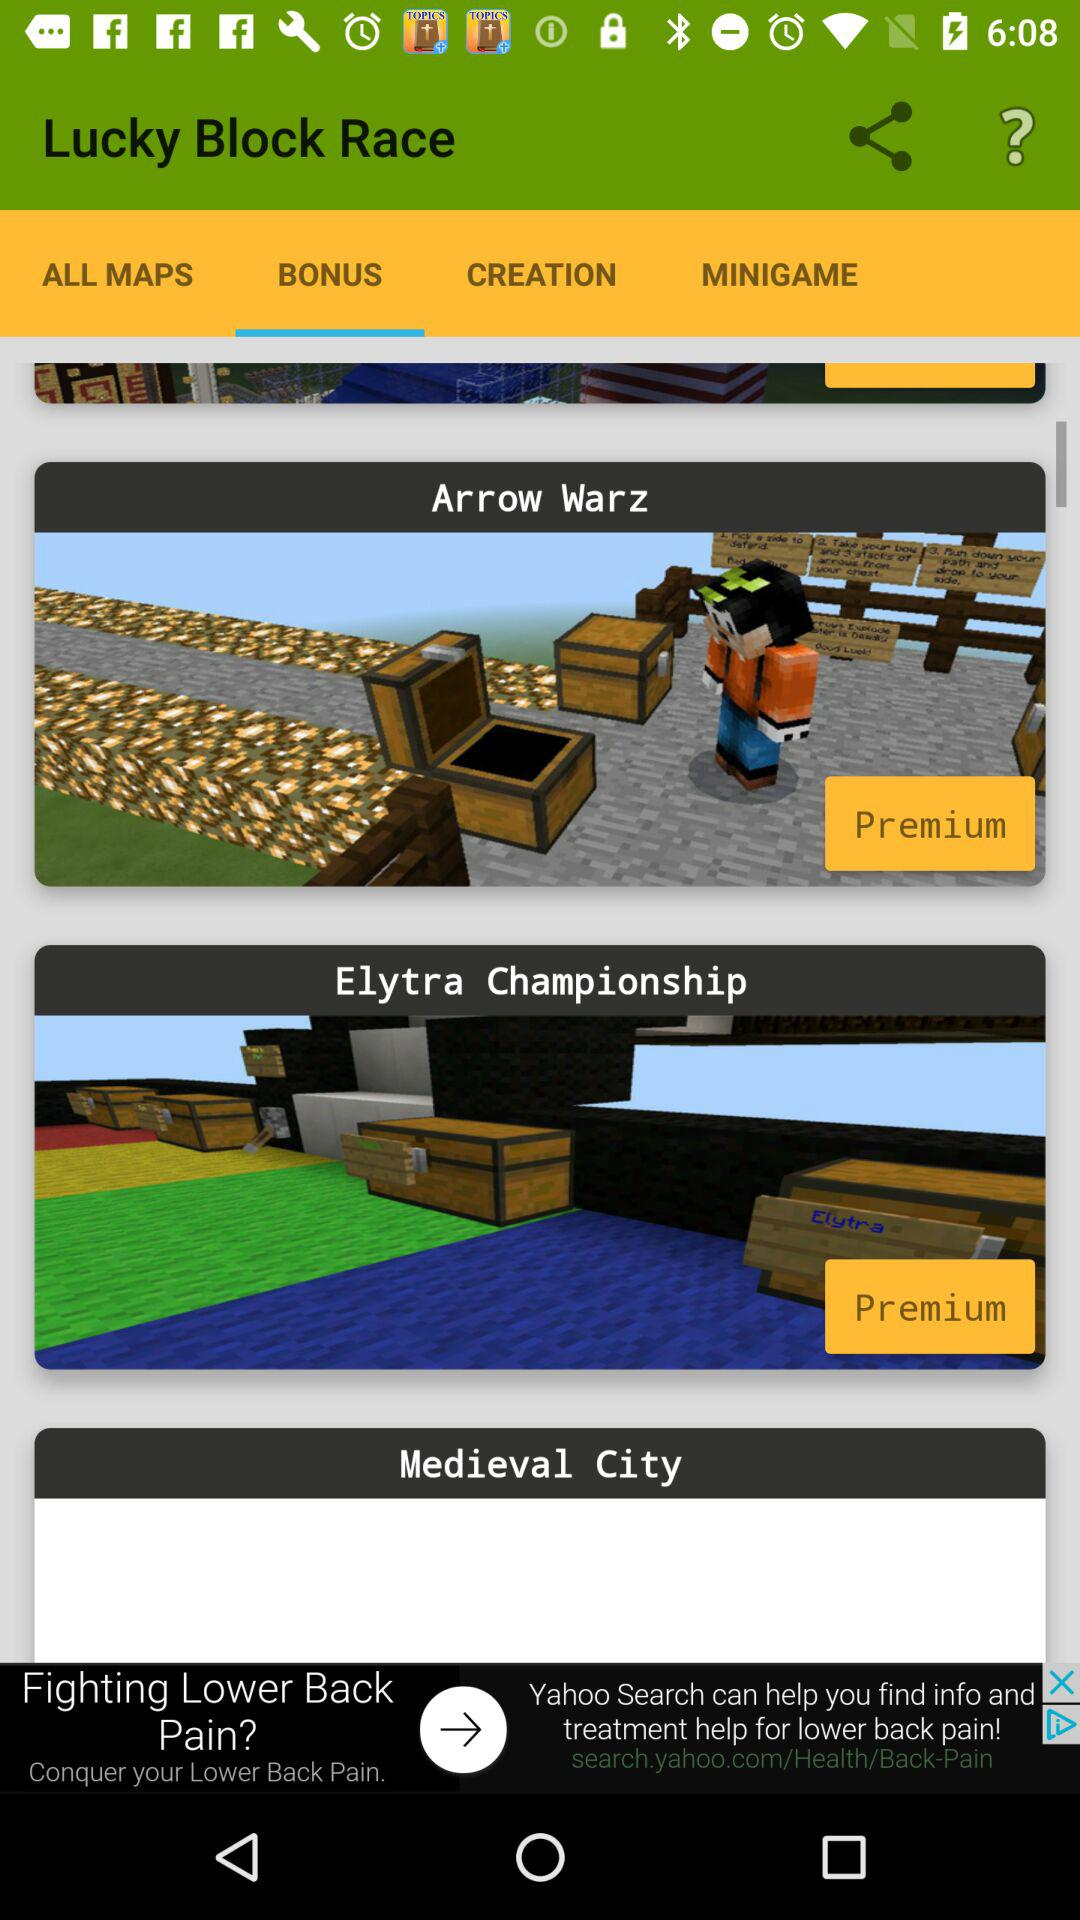Which tab is selected? The selected tab is "BONUS". 